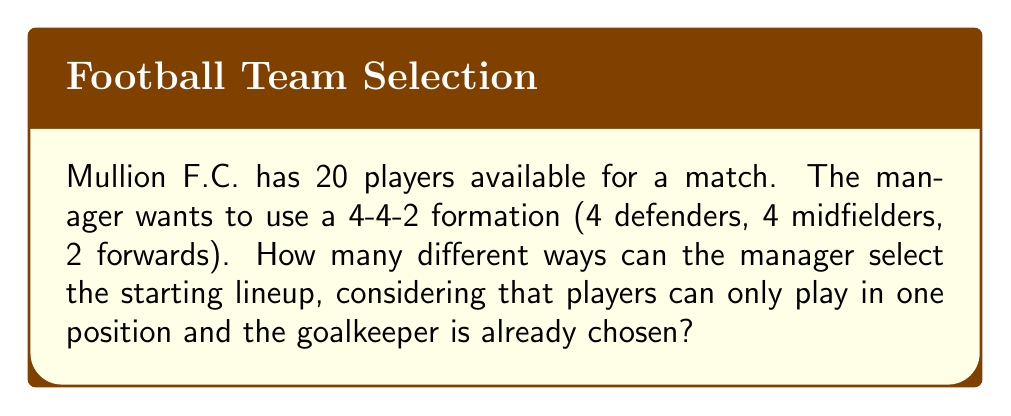Help me with this question. Let's approach this step-by-step using group theory concepts:

1) We have 19 outfield players (20 total - 1 goalkeeper) to choose from.

2) We need to select:
   - 4 defenders
   - 4 midfielders
   - 2 forwards

3) This is a combination problem. We can use the multiplication principle of counting.

4) For defenders: We choose 4 out of 19 players. This can be done in $\binom{19}{4}$ ways.

5) For midfielders: After selecting defenders, we have 15 players left. We choose 4 out of 15. This can be done in $\binom{15}{4}$ ways.

6) For forwards: We have 11 players left and need to choose 2. This can be done in $\binom{11}{2}$ ways.

7) The total number of ways to select the team is the product of these combinations:

   $$\binom{19}{4} \times \binom{15}{4} \times \binom{11}{2}$$

8) Let's calculate:
   $$\binom{19}{4} = 3876$$
   $$\binom{15}{4} = 1365$$
   $$\binom{11}{2} = 55$$

9) Therefore, the total number of possible lineups is:
   $$3876 \times 1365 \times 55 = 291,270,900$$

This large number demonstrates the flexibility in team selection that the Mullion F.C. manager has, even with a fixed formation.
Answer: 291,270,900 